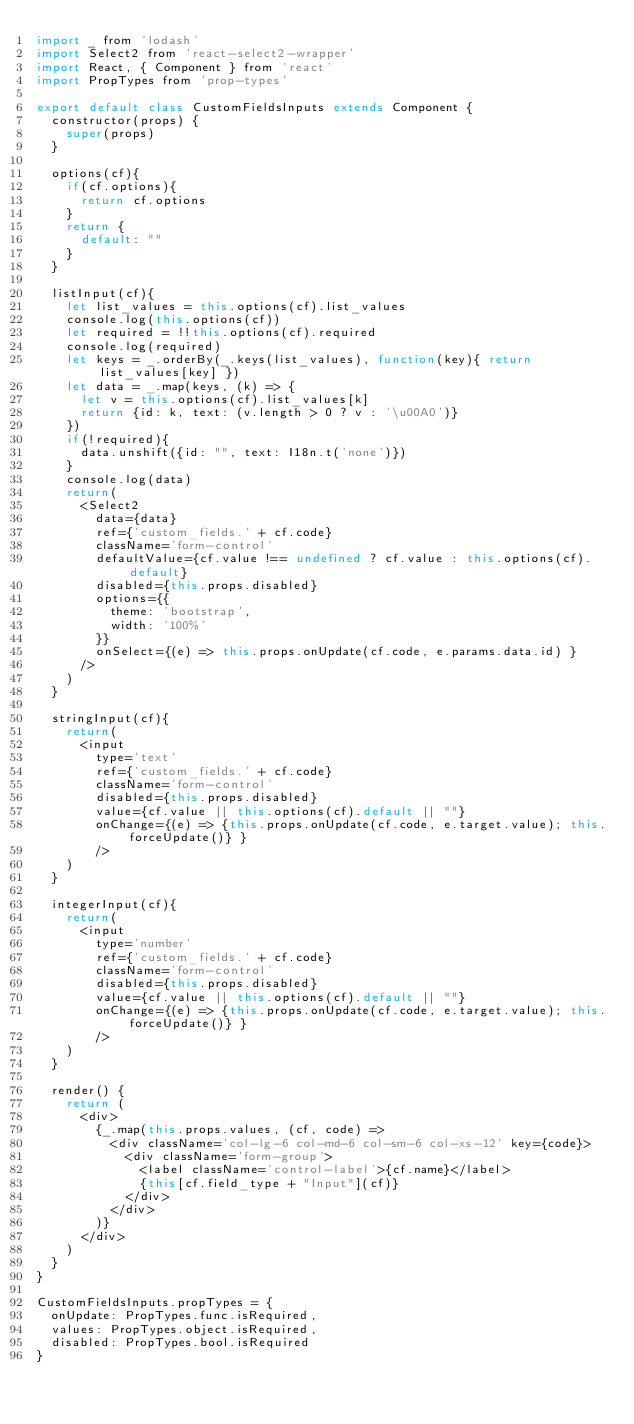Convert code to text. <code><loc_0><loc_0><loc_500><loc_500><_JavaScript_>import _ from 'lodash'
import Select2 from 'react-select2-wrapper'
import React, { Component } from 'react'
import PropTypes from 'prop-types'

export default class CustomFieldsInputs extends Component {
  constructor(props) {
    super(props)
  }

  options(cf){
    if(cf.options){
      return cf.options
    }
    return {
      default: ""
    }
  }

  listInput(cf){
    let list_values = this.options(cf).list_values
    console.log(this.options(cf))
    let required = !!this.options(cf).required
    console.log(required)
    let keys = _.orderBy(_.keys(list_values), function(key){ return list_values[key] })
    let data = _.map(keys, (k) => {
      let v = this.options(cf).list_values[k]
      return {id: k, text: (v.length > 0 ? v : '\u00A0')}
    })
    if(!required){
      data.unshift({id: "", text: I18n.t('none')})
    }
    console.log(data)
    return(
      <Select2
        data={data}
        ref={'custom_fields.' + cf.code}
        className='form-control'
        defaultValue={cf.value !== undefined ? cf.value : this.options(cf).default}
        disabled={this.props.disabled}
        options={{
          theme: 'bootstrap',
          width: '100%'
        }}
        onSelect={(e) => this.props.onUpdate(cf.code, e.params.data.id) }
      />
    )
  }

  stringInput(cf){
    return(
      <input
        type='text'
        ref={'custom_fields.' + cf.code}
        className='form-control'
        disabled={this.props.disabled}
        value={cf.value || this.options(cf).default || ""}
        onChange={(e) => {this.props.onUpdate(cf.code, e.target.value); this.forceUpdate()} }
        />
    )
  }

  integerInput(cf){
    return(
      <input
        type='number'
        ref={'custom_fields.' + cf.code}
        className='form-control'
        disabled={this.props.disabled}
        value={cf.value || this.options(cf).default || ""}
        onChange={(e) => {this.props.onUpdate(cf.code, e.target.value); this.forceUpdate()} }
        />
    )
  }

  render() {
    return (
      <div>
        {_.map(this.props.values, (cf, code) =>
          <div className='col-lg-6 col-md-6 col-sm-6 col-xs-12' key={code}>
            <div className='form-group'>
              <label className='control-label'>{cf.name}</label>
              {this[cf.field_type + "Input"](cf)}
            </div>
          </div>
        )}
      </div>
    )
  }
}

CustomFieldsInputs.propTypes = {
  onUpdate: PropTypes.func.isRequired,
  values: PropTypes.object.isRequired,
  disabled: PropTypes.bool.isRequired
}
</code> 